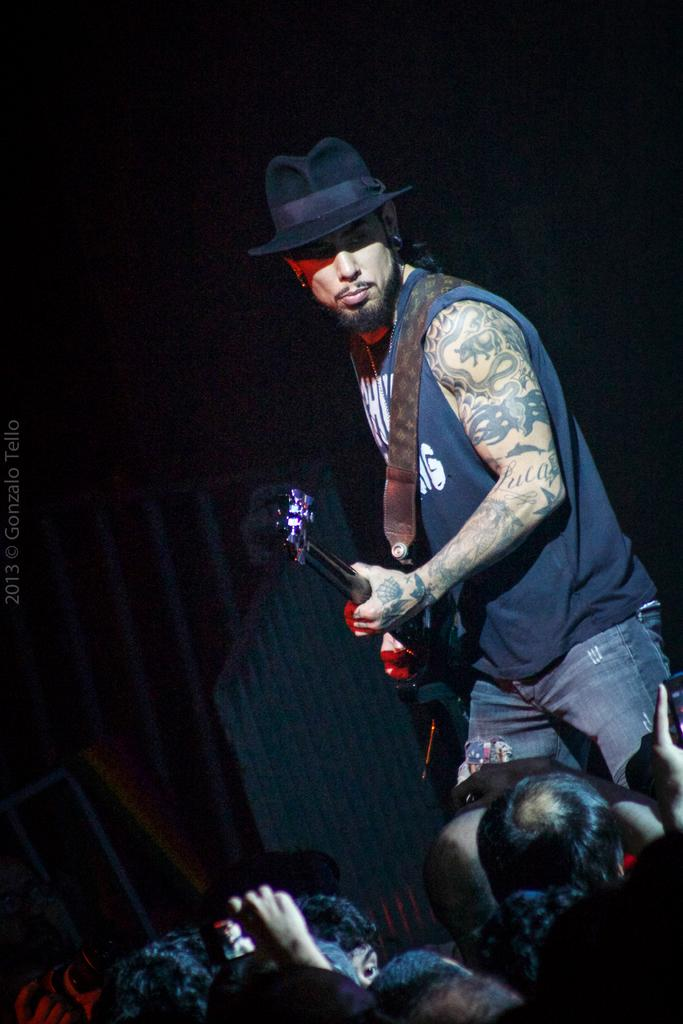What is the man in the image doing? The man is playing a guitar in the image. What is the man wearing on his head? The man is wearing a hat in the image. Can you describe the people in front of the man? There are people in front of the man, but their specific characteristics are not mentioned in the facts. What is the tendency of the moon in the image? There is no moon present in the image, so it is not possible to determine its tendency. 